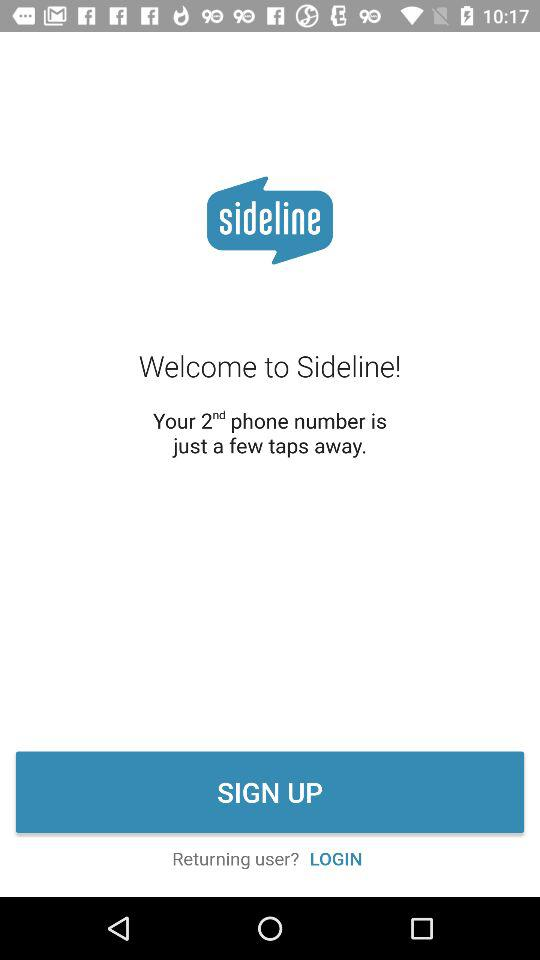What is the name of the application? The name of the application is "sideline". 